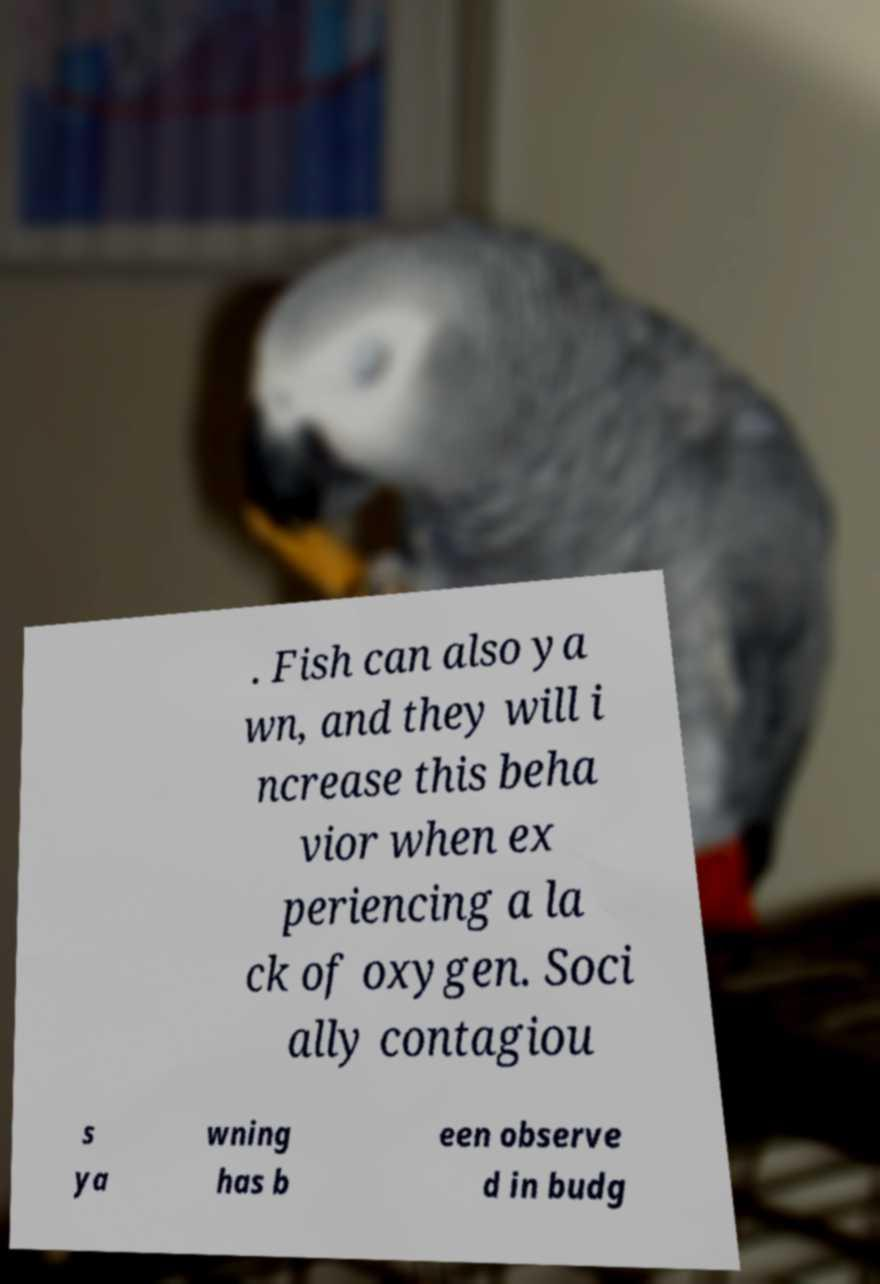Can you read and provide the text displayed in the image?This photo seems to have some interesting text. Can you extract and type it out for me? . Fish can also ya wn, and they will i ncrease this beha vior when ex periencing a la ck of oxygen. Soci ally contagiou s ya wning has b een observe d in budg 